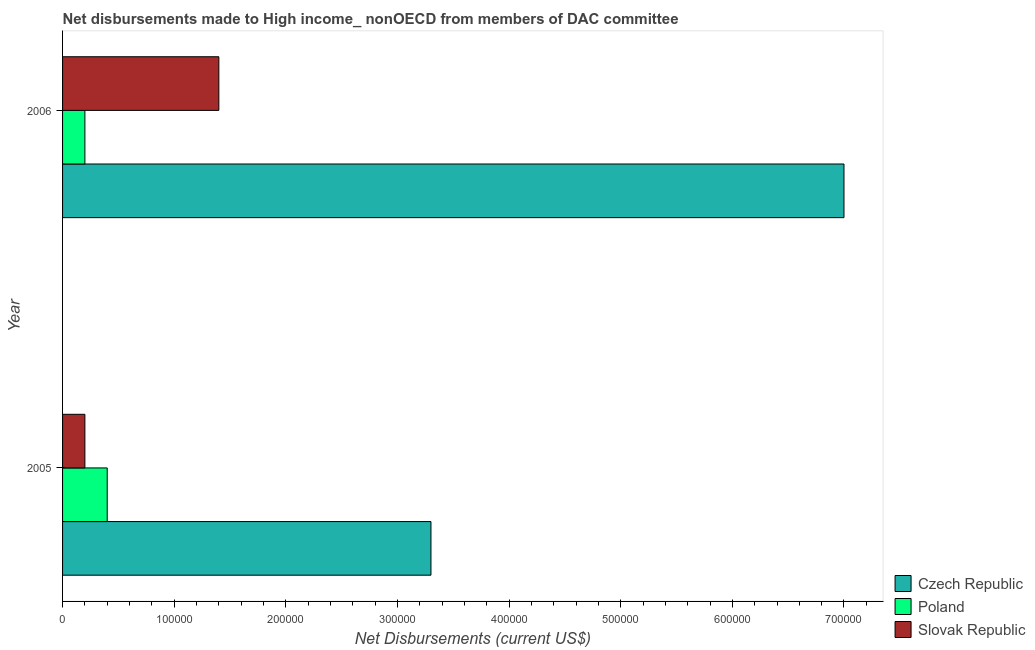How many different coloured bars are there?
Offer a terse response. 3. How many groups of bars are there?
Your response must be concise. 2. How many bars are there on the 1st tick from the top?
Make the answer very short. 3. How many bars are there on the 1st tick from the bottom?
Your answer should be very brief. 3. What is the label of the 1st group of bars from the top?
Keep it short and to the point. 2006. In how many cases, is the number of bars for a given year not equal to the number of legend labels?
Your answer should be compact. 0. What is the net disbursements made by poland in 2006?
Offer a very short reply. 2.00e+04. Across all years, what is the maximum net disbursements made by czech republic?
Make the answer very short. 7.00e+05. Across all years, what is the minimum net disbursements made by poland?
Your answer should be compact. 2.00e+04. In which year was the net disbursements made by slovak republic maximum?
Your response must be concise. 2006. In which year was the net disbursements made by slovak republic minimum?
Your answer should be compact. 2005. What is the total net disbursements made by poland in the graph?
Ensure brevity in your answer.  6.00e+04. What is the difference between the net disbursements made by czech republic in 2005 and that in 2006?
Provide a short and direct response. -3.70e+05. What is the difference between the net disbursements made by slovak republic in 2006 and the net disbursements made by poland in 2005?
Offer a very short reply. 1.00e+05. What is the average net disbursements made by czech republic per year?
Provide a succinct answer. 5.15e+05. In the year 2005, what is the difference between the net disbursements made by czech republic and net disbursements made by poland?
Provide a short and direct response. 2.90e+05. In how many years, is the net disbursements made by poland greater than 400000 US$?
Provide a short and direct response. 0. What is the ratio of the net disbursements made by czech republic in 2005 to that in 2006?
Ensure brevity in your answer.  0.47. Is the net disbursements made by slovak republic in 2005 less than that in 2006?
Make the answer very short. Yes. Is the difference between the net disbursements made by czech republic in 2005 and 2006 greater than the difference between the net disbursements made by poland in 2005 and 2006?
Provide a short and direct response. No. In how many years, is the net disbursements made by czech republic greater than the average net disbursements made by czech republic taken over all years?
Ensure brevity in your answer.  1. What does the 1st bar from the top in 2006 represents?
Make the answer very short. Slovak Republic. What does the 3rd bar from the bottom in 2005 represents?
Keep it short and to the point. Slovak Republic. Is it the case that in every year, the sum of the net disbursements made by czech republic and net disbursements made by poland is greater than the net disbursements made by slovak republic?
Ensure brevity in your answer.  Yes. How many bars are there?
Make the answer very short. 6. Are all the bars in the graph horizontal?
Give a very brief answer. Yes. What is the difference between two consecutive major ticks on the X-axis?
Provide a short and direct response. 1.00e+05. Are the values on the major ticks of X-axis written in scientific E-notation?
Offer a very short reply. No. Does the graph contain any zero values?
Offer a terse response. No. Does the graph contain grids?
Make the answer very short. No. Where does the legend appear in the graph?
Make the answer very short. Bottom right. How are the legend labels stacked?
Provide a short and direct response. Vertical. What is the title of the graph?
Your answer should be compact. Net disbursements made to High income_ nonOECD from members of DAC committee. What is the label or title of the X-axis?
Your answer should be very brief. Net Disbursements (current US$). What is the label or title of the Y-axis?
Make the answer very short. Year. What is the Net Disbursements (current US$) in Czech Republic in 2005?
Your response must be concise. 3.30e+05. What is the Net Disbursements (current US$) of Slovak Republic in 2005?
Give a very brief answer. 2.00e+04. What is the Net Disbursements (current US$) in Czech Republic in 2006?
Your answer should be very brief. 7.00e+05. What is the Net Disbursements (current US$) in Slovak Republic in 2006?
Your response must be concise. 1.40e+05. Across all years, what is the maximum Net Disbursements (current US$) of Czech Republic?
Your answer should be compact. 7.00e+05. Across all years, what is the maximum Net Disbursements (current US$) of Poland?
Provide a short and direct response. 4.00e+04. Across all years, what is the maximum Net Disbursements (current US$) of Slovak Republic?
Offer a very short reply. 1.40e+05. Across all years, what is the minimum Net Disbursements (current US$) of Czech Republic?
Provide a succinct answer. 3.30e+05. Across all years, what is the minimum Net Disbursements (current US$) in Slovak Republic?
Give a very brief answer. 2.00e+04. What is the total Net Disbursements (current US$) in Czech Republic in the graph?
Give a very brief answer. 1.03e+06. What is the total Net Disbursements (current US$) in Poland in the graph?
Ensure brevity in your answer.  6.00e+04. What is the difference between the Net Disbursements (current US$) in Czech Republic in 2005 and that in 2006?
Your answer should be very brief. -3.70e+05. What is the difference between the Net Disbursements (current US$) in Slovak Republic in 2005 and that in 2006?
Your response must be concise. -1.20e+05. What is the difference between the Net Disbursements (current US$) in Czech Republic in 2005 and the Net Disbursements (current US$) in Slovak Republic in 2006?
Provide a succinct answer. 1.90e+05. What is the difference between the Net Disbursements (current US$) in Poland in 2005 and the Net Disbursements (current US$) in Slovak Republic in 2006?
Provide a succinct answer. -1.00e+05. What is the average Net Disbursements (current US$) of Czech Republic per year?
Provide a succinct answer. 5.15e+05. What is the average Net Disbursements (current US$) in Slovak Republic per year?
Your answer should be very brief. 8.00e+04. In the year 2005, what is the difference between the Net Disbursements (current US$) in Poland and Net Disbursements (current US$) in Slovak Republic?
Your response must be concise. 2.00e+04. In the year 2006, what is the difference between the Net Disbursements (current US$) of Czech Republic and Net Disbursements (current US$) of Poland?
Give a very brief answer. 6.80e+05. In the year 2006, what is the difference between the Net Disbursements (current US$) of Czech Republic and Net Disbursements (current US$) of Slovak Republic?
Keep it short and to the point. 5.60e+05. In the year 2006, what is the difference between the Net Disbursements (current US$) in Poland and Net Disbursements (current US$) in Slovak Republic?
Your response must be concise. -1.20e+05. What is the ratio of the Net Disbursements (current US$) in Czech Republic in 2005 to that in 2006?
Keep it short and to the point. 0.47. What is the ratio of the Net Disbursements (current US$) in Poland in 2005 to that in 2006?
Your answer should be compact. 2. What is the ratio of the Net Disbursements (current US$) in Slovak Republic in 2005 to that in 2006?
Provide a succinct answer. 0.14. What is the difference between the highest and the lowest Net Disbursements (current US$) of Czech Republic?
Your response must be concise. 3.70e+05. What is the difference between the highest and the lowest Net Disbursements (current US$) of Slovak Republic?
Your response must be concise. 1.20e+05. 